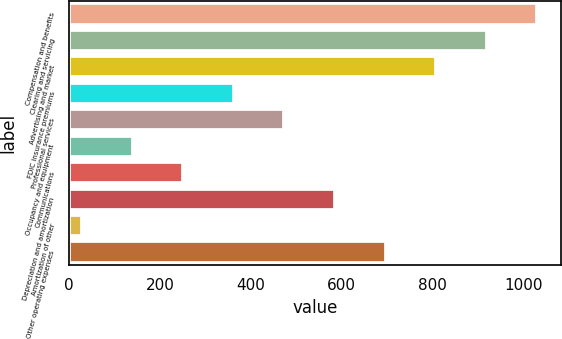Convert chart to OTSL. <chart><loc_0><loc_0><loc_500><loc_500><bar_chart><fcel>Compensation and benefits<fcel>Clearing and servicing<fcel>Advertising and market<fcel>FDIC insurance premiums<fcel>Professional services<fcel>Occupancy and equipment<fcel>Communications<fcel>Depreciation and amortization<fcel>Amortization of other<fcel>Other operating expenses<nl><fcel>1031.19<fcel>919.78<fcel>808.37<fcel>362.73<fcel>474.14<fcel>139.91<fcel>251.32<fcel>585.55<fcel>28.5<fcel>696.96<nl></chart> 